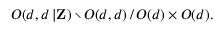<formula> <loc_0><loc_0><loc_500><loc_500>O ( d , d \, | { Z } ) \ O ( d , d ) \, / \, O ( d ) \times O ( d ) .</formula> 